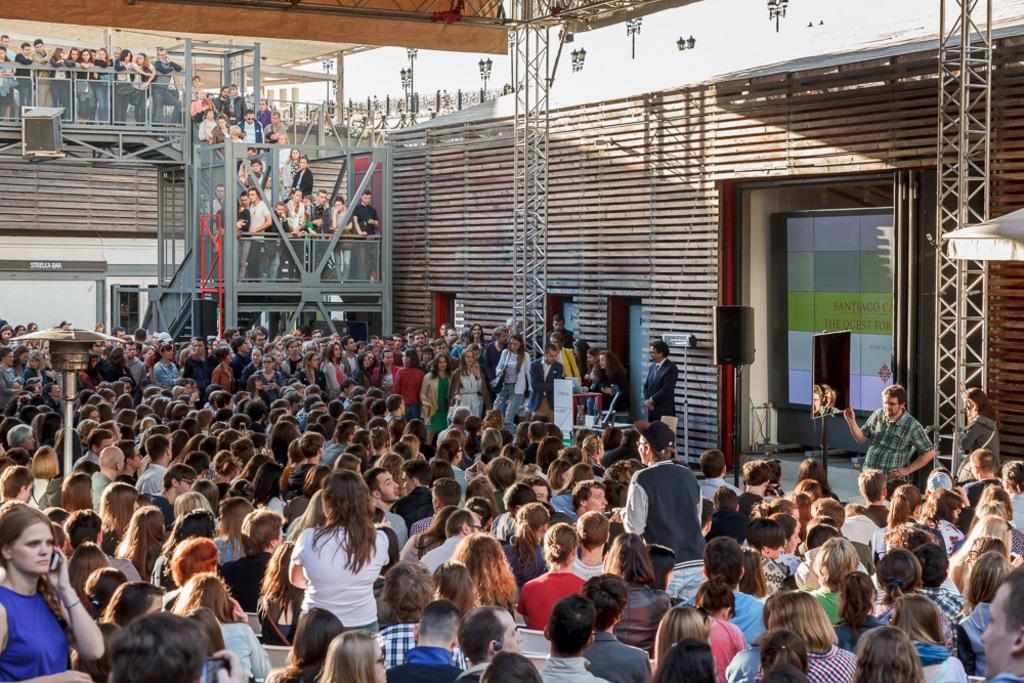In one or two sentences, can you explain what this image depicts? On the left side a beautiful girl is holding the mobile phone in her hand, she wore blue color top, in the middle a group of people are sitting. On the right side there is an electronic display and speakers in this image. 